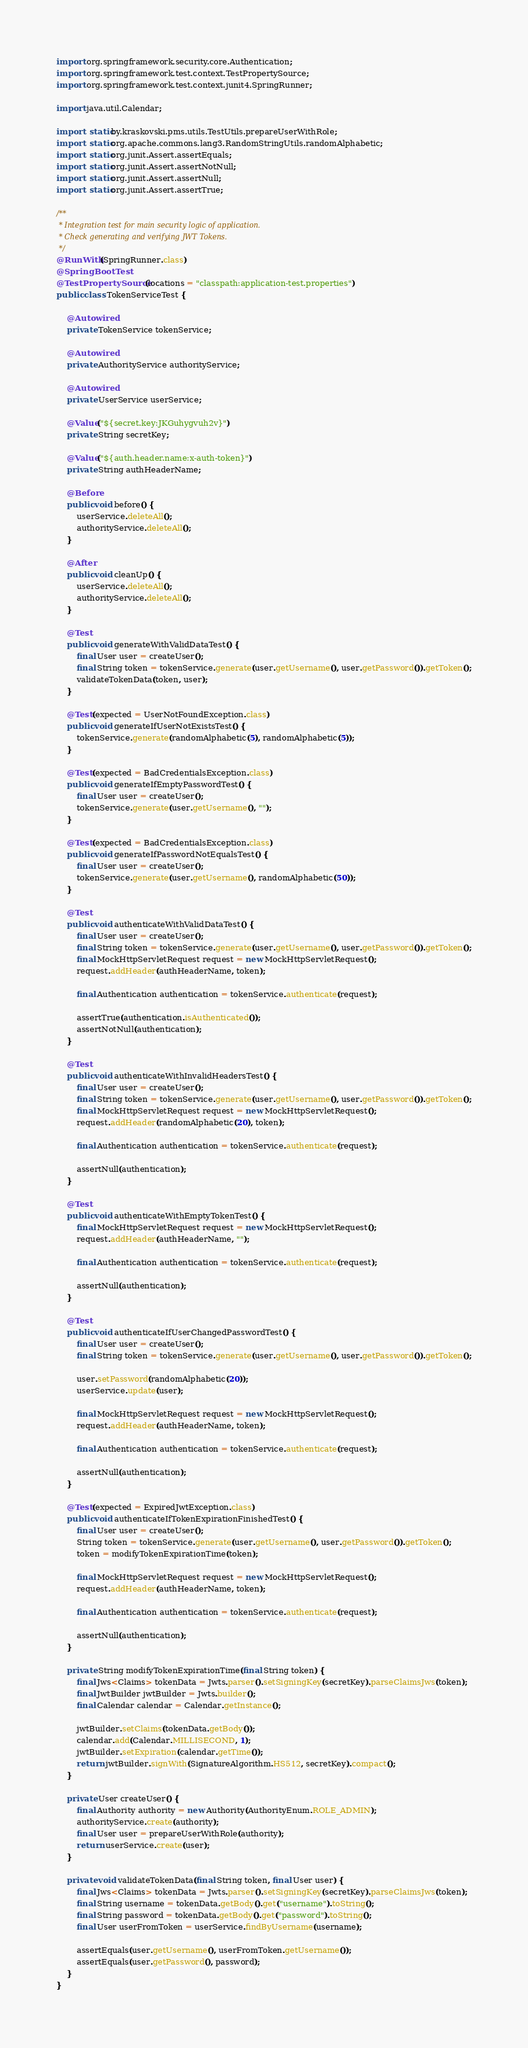<code> <loc_0><loc_0><loc_500><loc_500><_Java_>import org.springframework.security.core.Authentication;
import org.springframework.test.context.TestPropertySource;
import org.springframework.test.context.junit4.SpringRunner;

import java.util.Calendar;

import static by.kraskovski.pms.utils.TestUtils.prepareUserWithRole;
import static org.apache.commons.lang3.RandomStringUtils.randomAlphabetic;
import static org.junit.Assert.assertEquals;
import static org.junit.Assert.assertNotNull;
import static org.junit.Assert.assertNull;
import static org.junit.Assert.assertTrue;

/**
 * Integration test for main security logic of application.
 * Check generating and verifying JWT Tokens.
 */
@RunWith(SpringRunner.class)
@SpringBootTest
@TestPropertySource(locations = "classpath:application-test.properties")
public class TokenServiceTest {

    @Autowired
    private TokenService tokenService;

    @Autowired
    private AuthorityService authorityService;

    @Autowired
    private UserService userService;

    @Value("${secret.key:JKGuhygvuh2v}")
    private String secretKey;

    @Value("${auth.header.name:x-auth-token}")
    private String authHeaderName;

    @Before
    public void before() {
        userService.deleteAll();
        authorityService.deleteAll();
    }

    @After
    public void cleanUp() {
        userService.deleteAll();
        authorityService.deleteAll();
    }

    @Test
    public void generateWithValidDataTest() {
        final User user = createUser();
        final String token = tokenService.generate(user.getUsername(), user.getPassword()).getToken();
        validateTokenData(token, user);
    }

    @Test(expected = UserNotFoundException.class)
    public void generateIfUserNotExistsTest() {
        tokenService.generate(randomAlphabetic(5), randomAlphabetic(5));
    }

    @Test(expected = BadCredentialsException.class)
    public void generateIfEmptyPasswordTest() {
        final User user = createUser();
        tokenService.generate(user.getUsername(), "");
    }

    @Test(expected = BadCredentialsException.class)
    public void generateIfPasswordNotEqualsTest() {
        final User user = createUser();
        tokenService.generate(user.getUsername(), randomAlphabetic(50));
    }

    @Test
    public void authenticateWithValidDataTest() {
        final User user = createUser();
        final String token = tokenService.generate(user.getUsername(), user.getPassword()).getToken();
        final MockHttpServletRequest request = new MockHttpServletRequest();
        request.addHeader(authHeaderName, token);

        final Authentication authentication = tokenService.authenticate(request);

        assertTrue(authentication.isAuthenticated());
        assertNotNull(authentication);
    }

    @Test
    public void authenticateWithInvalidHeadersTest() {
        final User user = createUser();
        final String token = tokenService.generate(user.getUsername(), user.getPassword()).getToken();
        final MockHttpServletRequest request = new MockHttpServletRequest();
        request.addHeader(randomAlphabetic(20), token);

        final Authentication authentication = tokenService.authenticate(request);

        assertNull(authentication);
    }

    @Test
    public void authenticateWithEmptyTokenTest() {
        final MockHttpServletRequest request = new MockHttpServletRequest();
        request.addHeader(authHeaderName, "");

        final Authentication authentication = tokenService.authenticate(request);

        assertNull(authentication);
    }

    @Test
    public void authenticateIfUserChangedPasswordTest() {
        final User user = createUser();
        final String token = tokenService.generate(user.getUsername(), user.getPassword()).getToken();

        user.setPassword(randomAlphabetic(20));
        userService.update(user);

        final MockHttpServletRequest request = new MockHttpServletRequest();
        request.addHeader(authHeaderName, token);

        final Authentication authentication = tokenService.authenticate(request);

        assertNull(authentication);
    }

    @Test(expected = ExpiredJwtException.class)
    public void authenticateIfTokenExpirationFinishedTest() {
        final User user = createUser();
        String token = tokenService.generate(user.getUsername(), user.getPassword()).getToken();
        token = modifyTokenExpirationTime(token);

        final MockHttpServletRequest request = new MockHttpServletRequest();
        request.addHeader(authHeaderName, token);

        final Authentication authentication = tokenService.authenticate(request);

        assertNull(authentication);
    }

    private String modifyTokenExpirationTime(final String token) {
        final Jws<Claims> tokenData = Jwts.parser().setSigningKey(secretKey).parseClaimsJws(token);
        final JwtBuilder jwtBuilder = Jwts.builder();
        final Calendar calendar = Calendar.getInstance();

        jwtBuilder.setClaims(tokenData.getBody());
        calendar.add(Calendar.MILLISECOND, 1);
        jwtBuilder.setExpiration(calendar.getTime());
        return jwtBuilder.signWith(SignatureAlgorithm.HS512, secretKey).compact();
    }

    private User createUser() {
        final Authority authority = new Authority(AuthorityEnum.ROLE_ADMIN);
        authorityService.create(authority);
        final User user = prepareUserWithRole(authority);
        return userService.create(user);
    }

    private void validateTokenData(final String token, final User user) {
        final Jws<Claims> tokenData = Jwts.parser().setSigningKey(secretKey).parseClaimsJws(token);
        final String username = tokenData.getBody().get("username").toString();
        final String password = tokenData.getBody().get("password").toString();
        final User userFromToken = userService.findByUsername(username);

        assertEquals(user.getUsername(), userFromToken.getUsername());
        assertEquals(user.getPassword(), password);
    }
}
</code> 